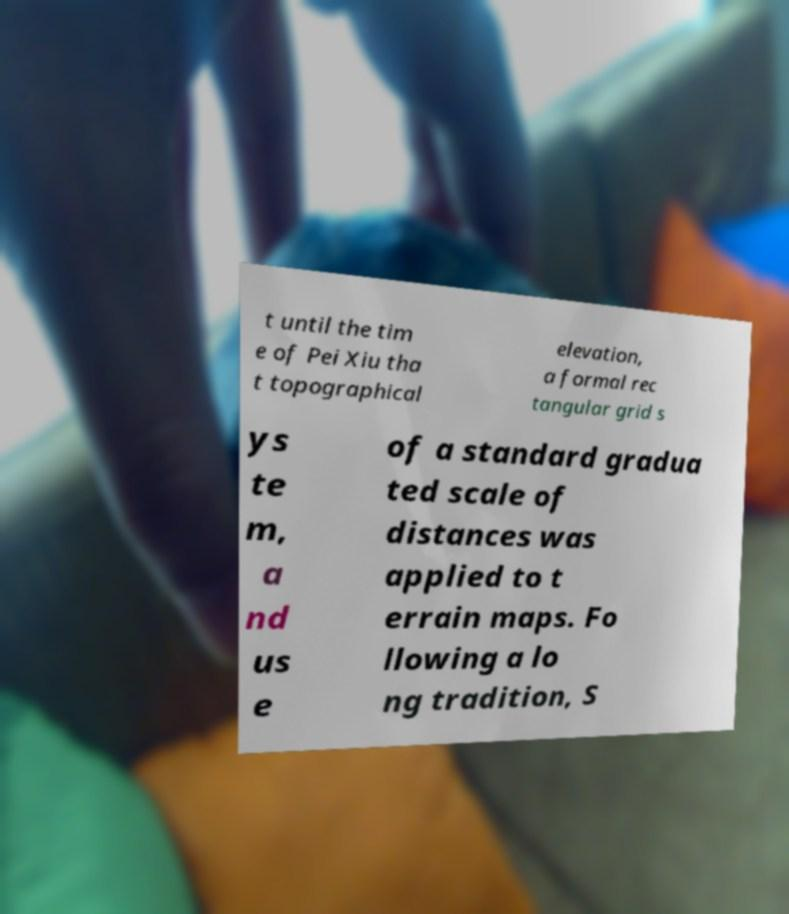What messages or text are displayed in this image? I need them in a readable, typed format. t until the tim e of Pei Xiu tha t topographical elevation, a formal rec tangular grid s ys te m, a nd us e of a standard gradua ted scale of distances was applied to t errain maps. Fo llowing a lo ng tradition, S 